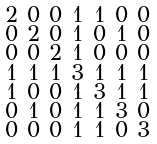Convert formula to latex. <formula><loc_0><loc_0><loc_500><loc_500>\begin{smallmatrix} 2 & 0 & 0 & 1 & 1 & 0 & 0 \\ 0 & 2 & 0 & 1 & 0 & 1 & 0 \\ 0 & 0 & 2 & 1 & 0 & 0 & 0 \\ 1 & 1 & 1 & 3 & 1 & 1 & 1 \\ 1 & 0 & 0 & 1 & 3 & 1 & 1 \\ 0 & 1 & 0 & 1 & 1 & 3 & 0 \\ 0 & 0 & 0 & 1 & 1 & 0 & 3 \end{smallmatrix}</formula> 